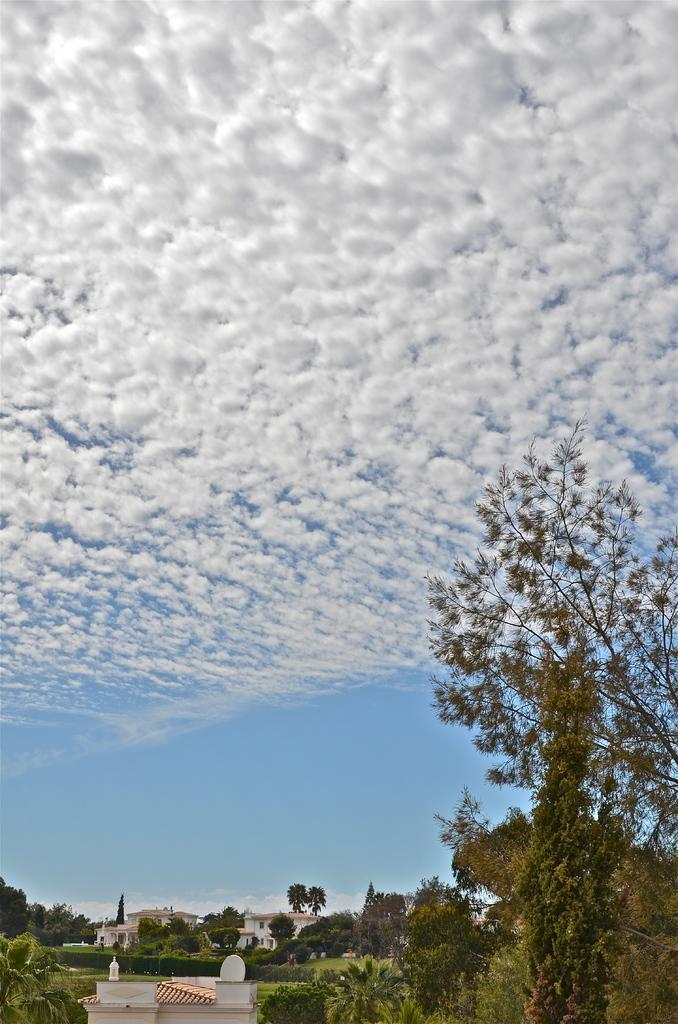What type of structures can be seen in the image? There are houses and buildings in the image. What type of natural elements are present in the image? A: There are trees and plants in the image. What is visible in the sky in the image? There are clouds visible in the sky in the image. How many deer can be seen grazing in the image? There are no deer present in the image. What is the range of the buildings in the image? The range of the buildings cannot be determined from the image alone, as there is no reference point for comparison. 